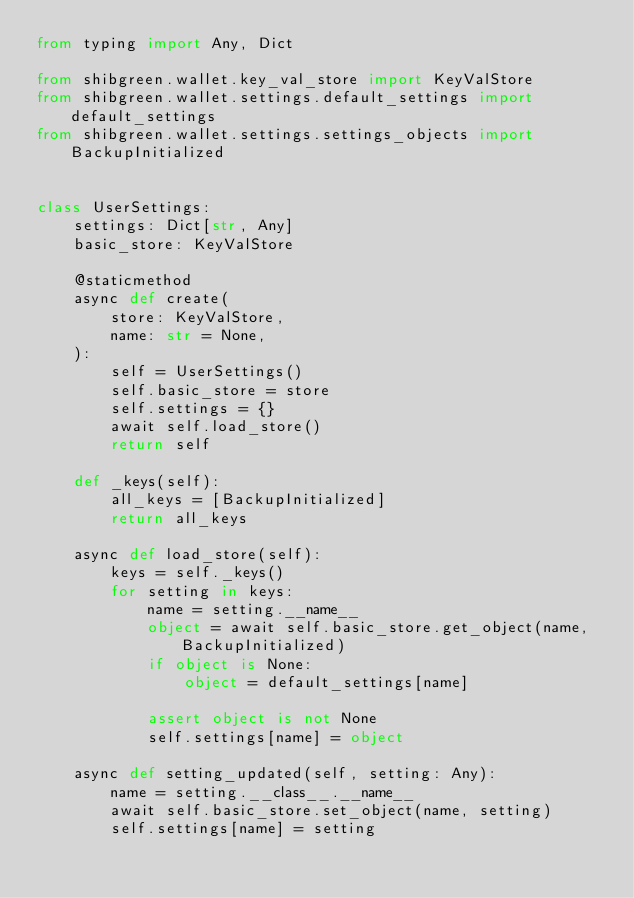Convert code to text. <code><loc_0><loc_0><loc_500><loc_500><_Python_>from typing import Any, Dict

from shibgreen.wallet.key_val_store import KeyValStore
from shibgreen.wallet.settings.default_settings import default_settings
from shibgreen.wallet.settings.settings_objects import BackupInitialized


class UserSettings:
    settings: Dict[str, Any]
    basic_store: KeyValStore

    @staticmethod
    async def create(
        store: KeyValStore,
        name: str = None,
    ):
        self = UserSettings()
        self.basic_store = store
        self.settings = {}
        await self.load_store()
        return self

    def _keys(self):
        all_keys = [BackupInitialized]
        return all_keys

    async def load_store(self):
        keys = self._keys()
        for setting in keys:
            name = setting.__name__
            object = await self.basic_store.get_object(name, BackupInitialized)
            if object is None:
                object = default_settings[name]

            assert object is not None
            self.settings[name] = object

    async def setting_updated(self, setting: Any):
        name = setting.__class__.__name__
        await self.basic_store.set_object(name, setting)
        self.settings[name] = setting
</code> 